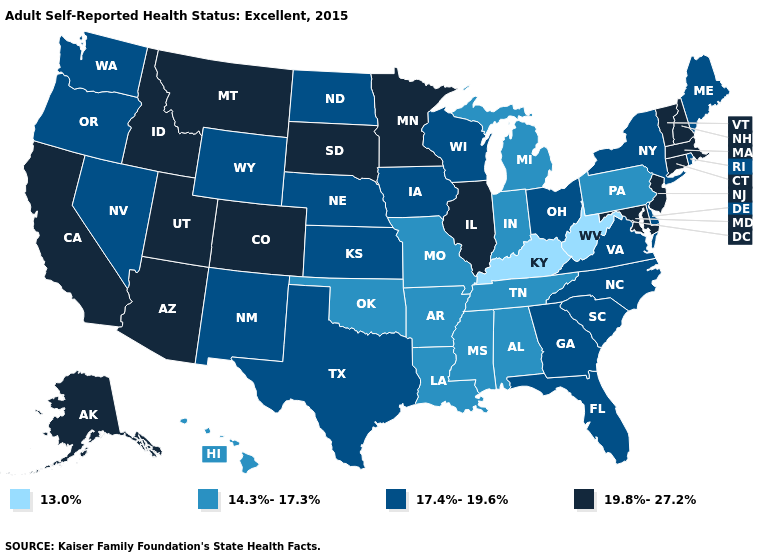Which states have the lowest value in the USA?
Answer briefly. Kentucky, West Virginia. Among the states that border Nevada , which have the highest value?
Be succinct. Arizona, California, Idaho, Utah. Does the first symbol in the legend represent the smallest category?
Give a very brief answer. Yes. What is the value of Utah?
Short answer required. 19.8%-27.2%. What is the value of Texas?
Be succinct. 17.4%-19.6%. Which states hav the highest value in the West?
Quick response, please. Alaska, Arizona, California, Colorado, Idaho, Montana, Utah. Among the states that border Montana , which have the lowest value?
Be succinct. North Dakota, Wyoming. Among the states that border Alabama , which have the lowest value?
Concise answer only. Mississippi, Tennessee. Which states have the lowest value in the West?
Quick response, please. Hawaii. Name the states that have a value in the range 17.4%-19.6%?
Keep it brief. Delaware, Florida, Georgia, Iowa, Kansas, Maine, Nebraska, Nevada, New Mexico, New York, North Carolina, North Dakota, Ohio, Oregon, Rhode Island, South Carolina, Texas, Virginia, Washington, Wisconsin, Wyoming. Name the states that have a value in the range 13.0%?
Answer briefly. Kentucky, West Virginia. What is the value of Massachusetts?
Be succinct. 19.8%-27.2%. What is the value of Michigan?
Answer briefly. 14.3%-17.3%. Among the states that border Idaho , does Oregon have the highest value?
Be succinct. No. 